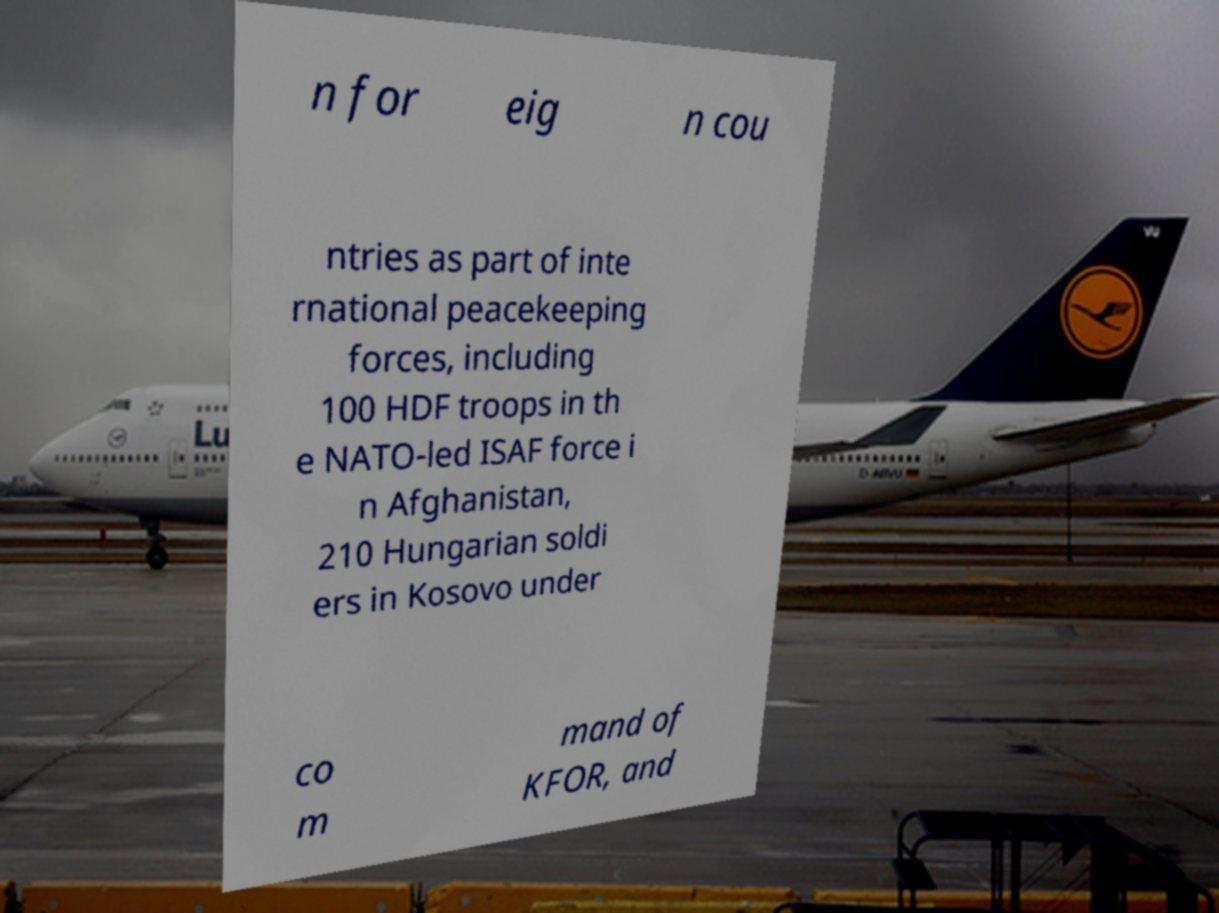There's text embedded in this image that I need extracted. Can you transcribe it verbatim? n for eig n cou ntries as part of inte rnational peacekeeping forces, including 100 HDF troops in th e NATO-led ISAF force i n Afghanistan, 210 Hungarian soldi ers in Kosovo under co m mand of KFOR, and 